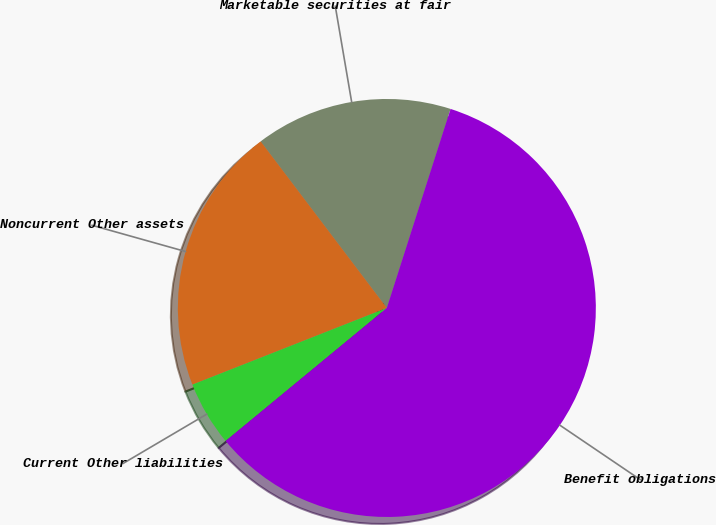<chart> <loc_0><loc_0><loc_500><loc_500><pie_chart><fcel>Marketable securities at fair<fcel>Noncurrent Other assets<fcel>Current Other liabilities<fcel>Benefit obligations<nl><fcel>15.25%<fcel>20.66%<fcel>5.0%<fcel>59.09%<nl></chart> 